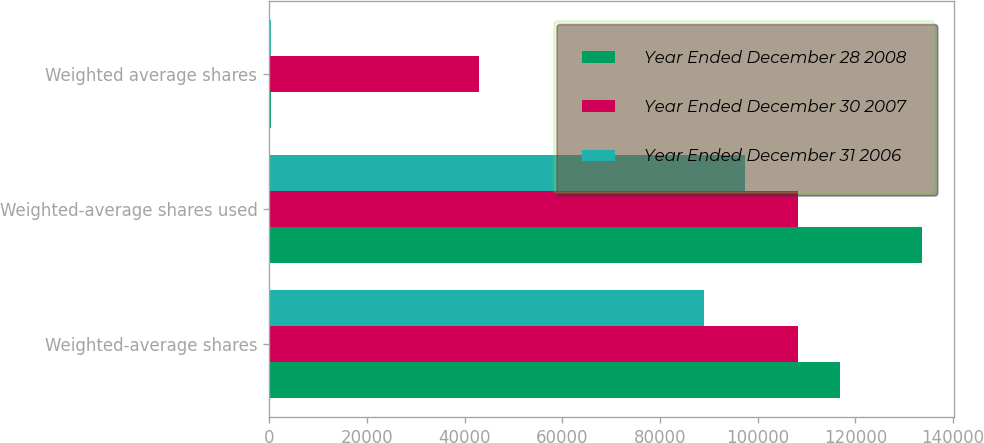Convert chart to OTSL. <chart><loc_0><loc_0><loc_500><loc_500><stacked_bar_chart><ecel><fcel>Weighted-average shares<fcel>Weighted-average shares used<fcel>Weighted average shares<nl><fcel>Year Ended December 28 2008<fcel>116855<fcel>133607<fcel>370<nl><fcel>Year Ended December 30 2007<fcel>108328<fcel>108308<fcel>42882<nl><fcel>Year Ended December 31 2006<fcel>89074<fcel>97508<fcel>401<nl></chart> 